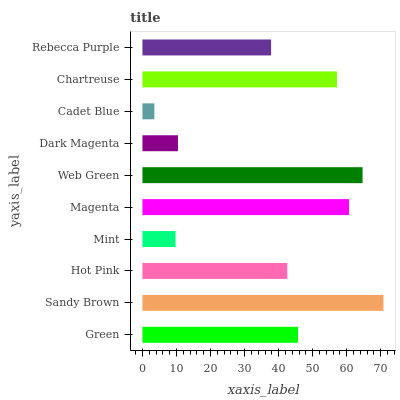Is Cadet Blue the minimum?
Answer yes or no. Yes. Is Sandy Brown the maximum?
Answer yes or no. Yes. Is Hot Pink the minimum?
Answer yes or no. No. Is Hot Pink the maximum?
Answer yes or no. No. Is Sandy Brown greater than Hot Pink?
Answer yes or no. Yes. Is Hot Pink less than Sandy Brown?
Answer yes or no. Yes. Is Hot Pink greater than Sandy Brown?
Answer yes or no. No. Is Sandy Brown less than Hot Pink?
Answer yes or no. No. Is Green the high median?
Answer yes or no. Yes. Is Hot Pink the low median?
Answer yes or no. Yes. Is Hot Pink the high median?
Answer yes or no. No. Is Rebecca Purple the low median?
Answer yes or no. No. 